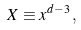<formula> <loc_0><loc_0><loc_500><loc_500>X \equiv x ^ { d - 3 } \, ,</formula> 